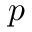<formula> <loc_0><loc_0><loc_500><loc_500>p</formula> 